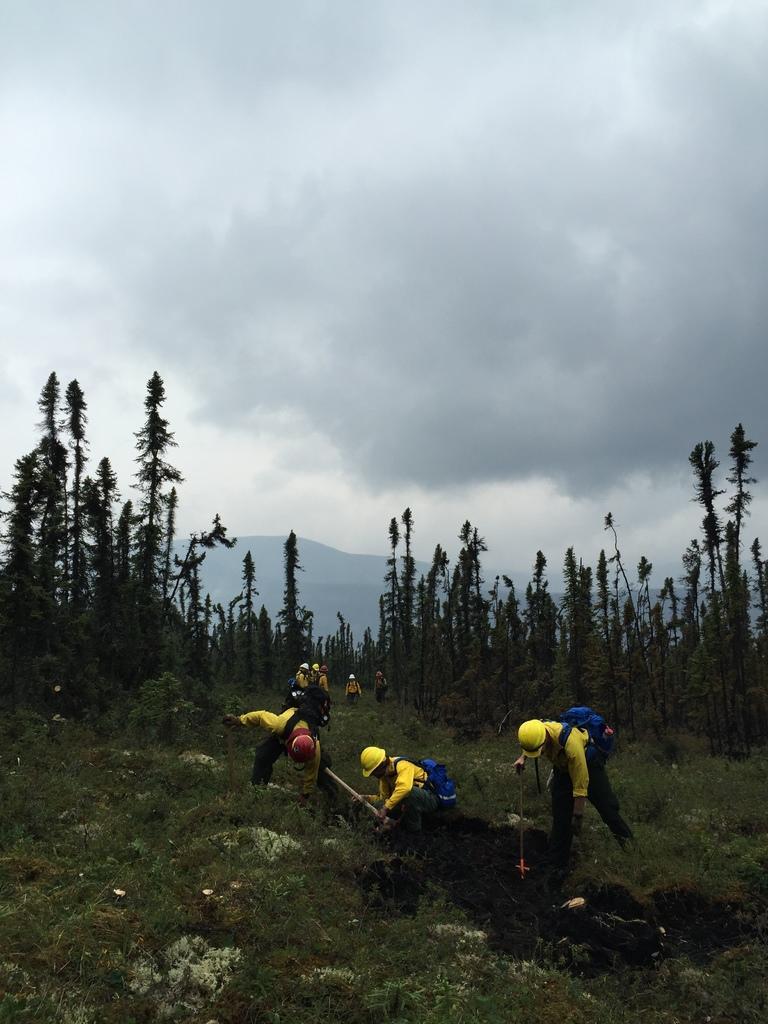Describe this image in one or two sentences. In this image I can see some people. I can see the grass. In the background, I can see the trees and clouds in the sky. 